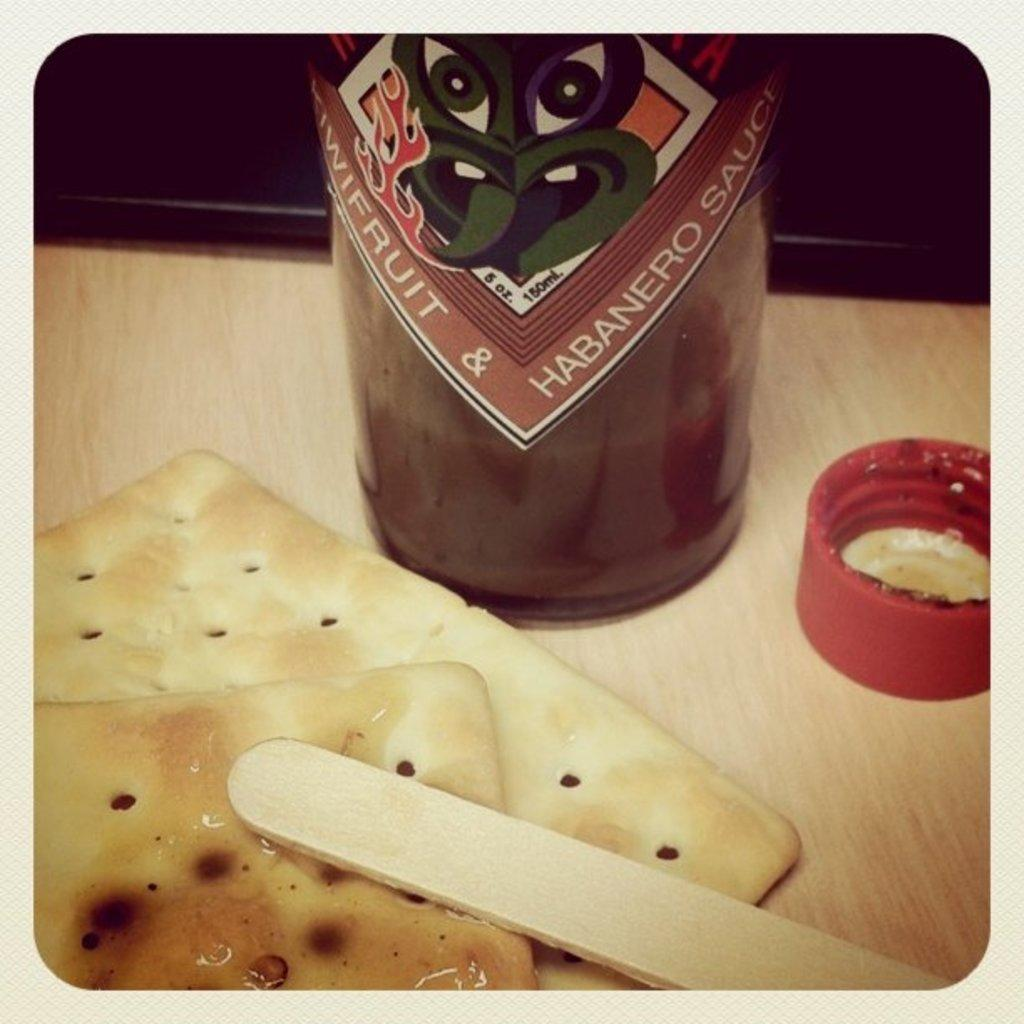What is located at the bottom of the image? There is a table at the bottom of the image. What is on the table in the image? There is food, a cap, a bottle, and a wooden stick on the table. Can you describe the bottle on the table? The bottle is on the table, but its contents or type are not specified in the facts. What might be used to stir or consume the food on the table? The wooden stick on the table might be used to stir or consume the food. Who is the expert in the image? There is no indication of an expert or any people in the image. What type of waste is present in the image? There is no waste present in the image; only a table, food, a cap, a bottle, and a wooden stick are mentioned. 